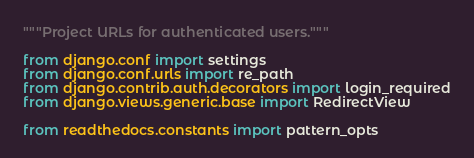<code> <loc_0><loc_0><loc_500><loc_500><_Python_>"""Project URLs for authenticated users."""

from django.conf import settings
from django.conf.urls import re_path
from django.contrib.auth.decorators import login_required
from django.views.generic.base import RedirectView

from readthedocs.constants import pattern_opts</code> 